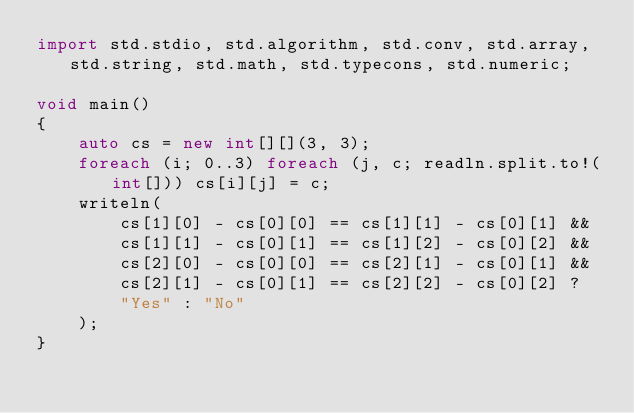<code> <loc_0><loc_0><loc_500><loc_500><_D_>import std.stdio, std.algorithm, std.conv, std.array, std.string, std.math, std.typecons, std.numeric;

void main()
{
    auto cs = new int[][](3, 3);
    foreach (i; 0..3) foreach (j, c; readln.split.to!(int[])) cs[i][j] = c;
    writeln(
        cs[1][0] - cs[0][0] == cs[1][1] - cs[0][1] &&
        cs[1][1] - cs[0][1] == cs[1][2] - cs[0][2] &&
        cs[2][0] - cs[0][0] == cs[2][1] - cs[0][1] &&
        cs[2][1] - cs[0][1] == cs[2][2] - cs[0][2] ?
        "Yes" : "No"
    );
}</code> 